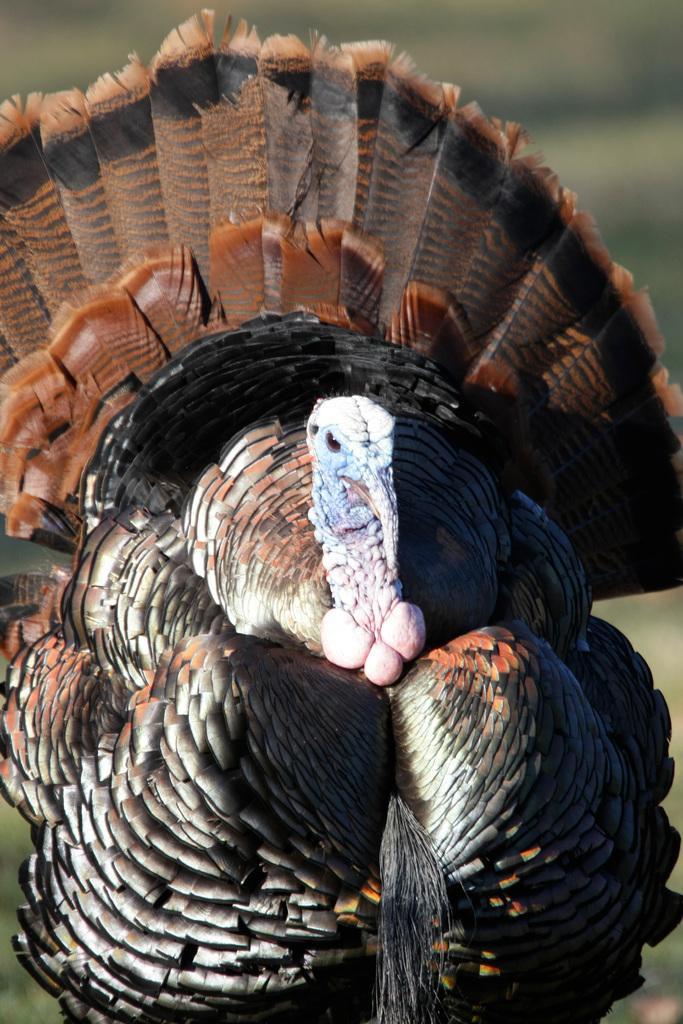Describe this image in one or two sentences. In this image, we can see a bird and the blurred background. 